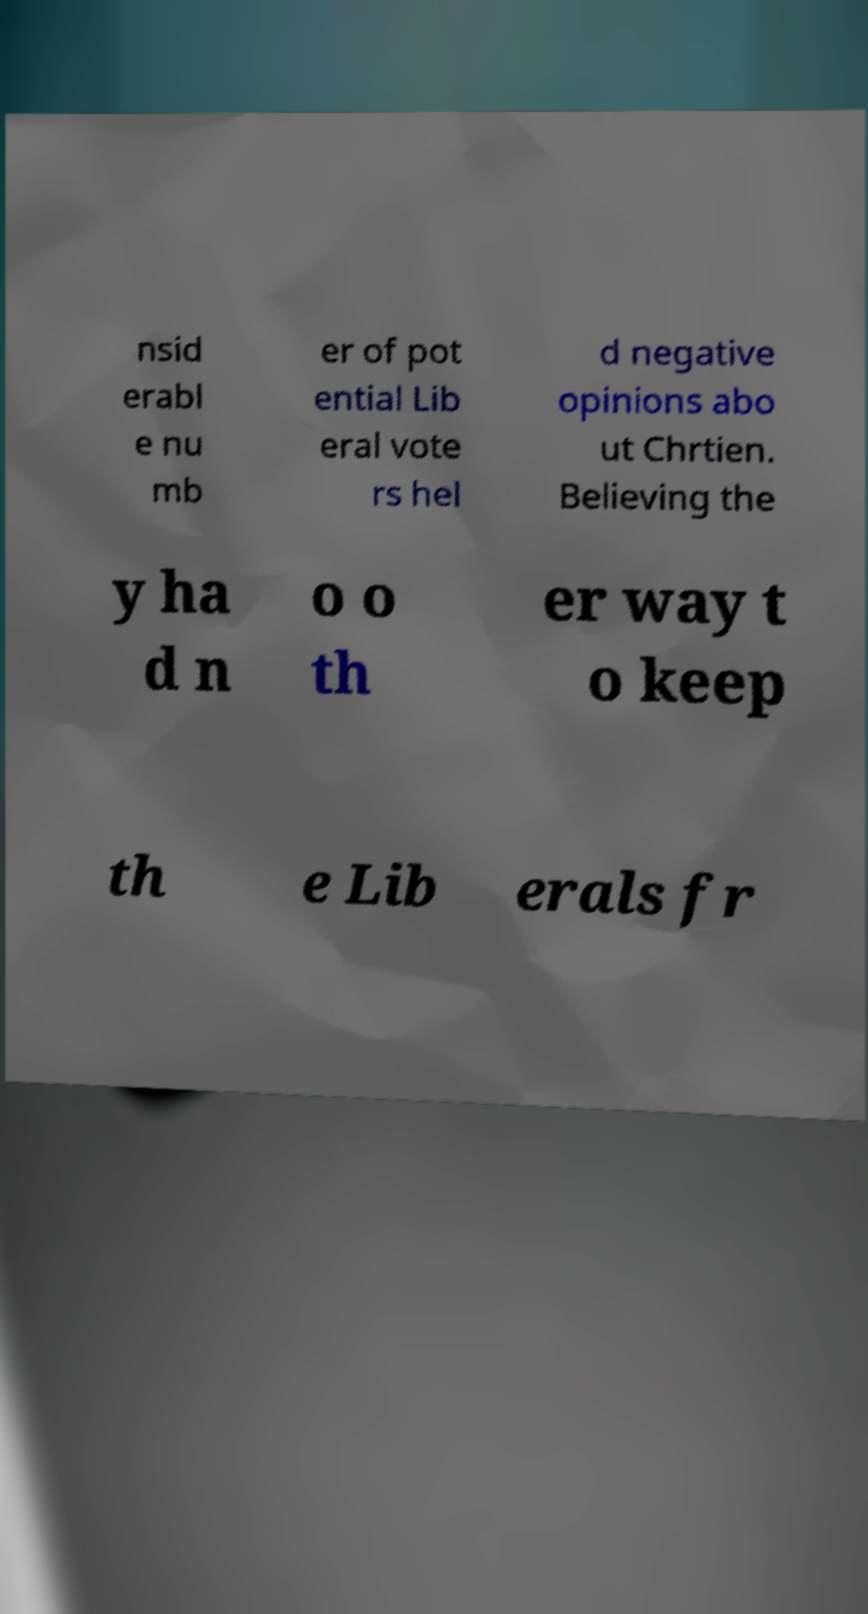Could you extract and type out the text from this image? nsid erabl e nu mb er of pot ential Lib eral vote rs hel d negative opinions abo ut Chrtien. Believing the y ha d n o o th er way t o keep th e Lib erals fr 